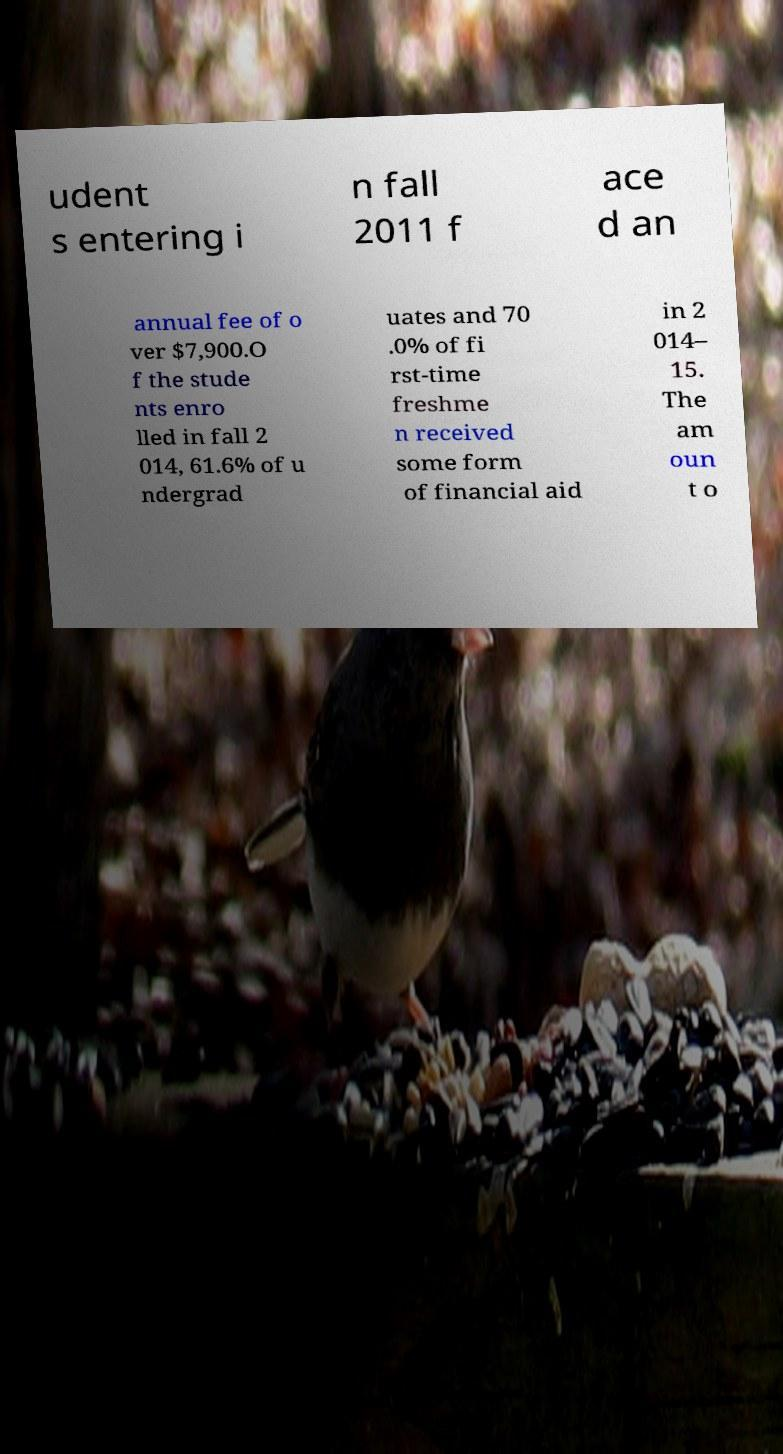For documentation purposes, I need the text within this image transcribed. Could you provide that? udent s entering i n fall 2011 f ace d an annual fee of o ver $7,900.O f the stude nts enro lled in fall 2 014, 61.6% of u ndergrad uates and 70 .0% of fi rst-time freshme n received some form of financial aid in 2 014– 15. The am oun t o 